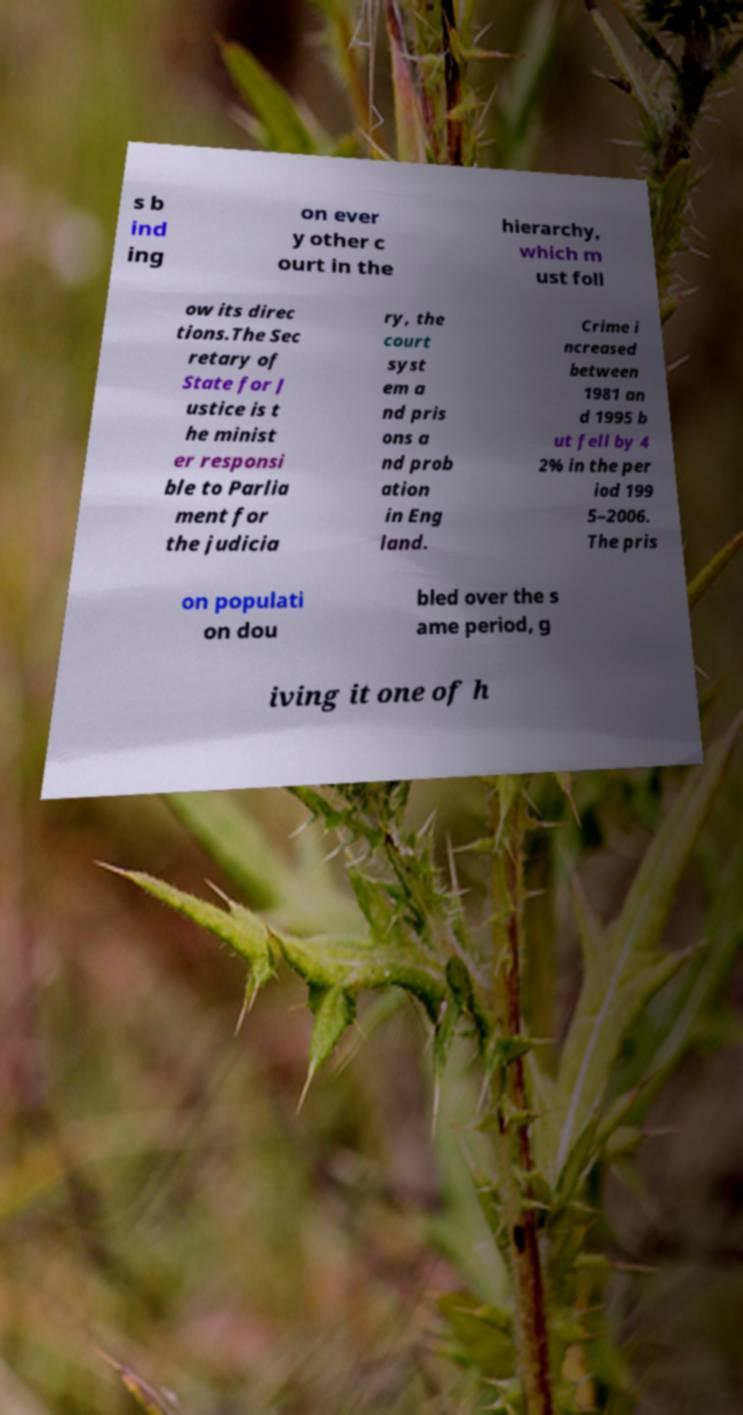Can you accurately transcribe the text from the provided image for me? s b ind ing on ever y other c ourt in the hierarchy, which m ust foll ow its direc tions.The Sec retary of State for J ustice is t he minist er responsi ble to Parlia ment for the judicia ry, the court syst em a nd pris ons a nd prob ation in Eng land. Crime i ncreased between 1981 an d 1995 b ut fell by 4 2% in the per iod 199 5–2006. The pris on populati on dou bled over the s ame period, g iving it one of h 